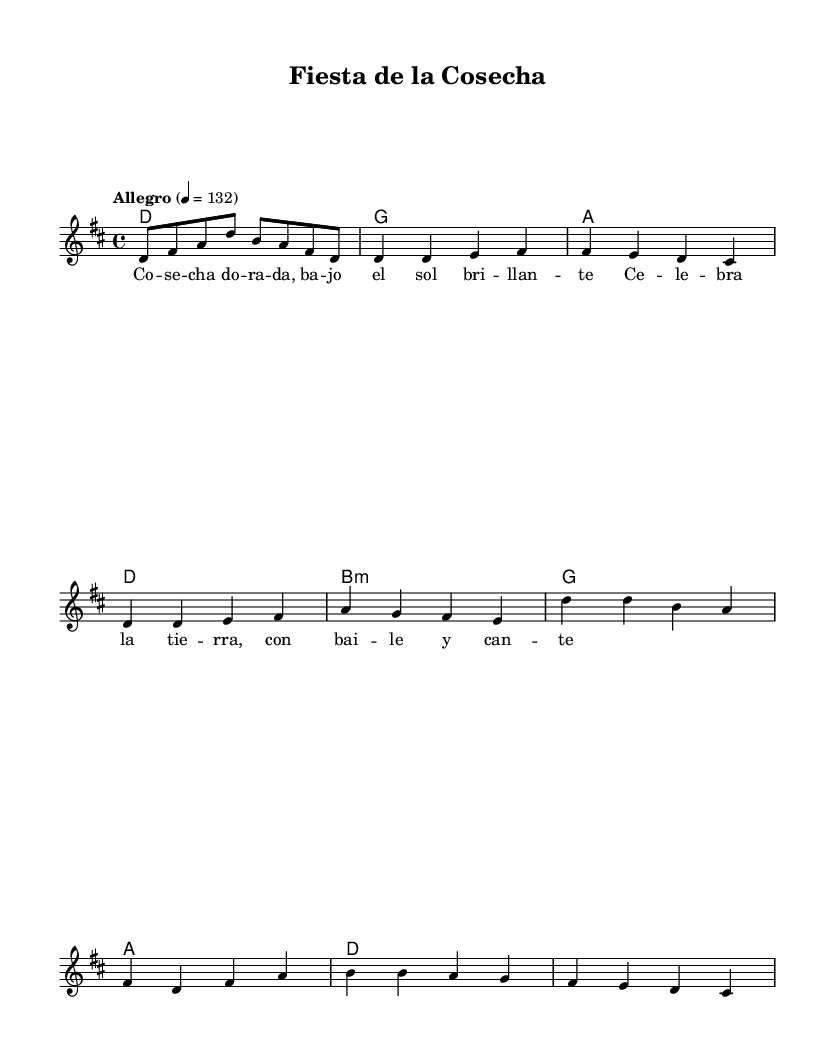What is the key signature of this music? The key signature is indicated by the presence of two sharps (F# and C#) at the beginning of the staff, which denotes the key of D major.
Answer: D major What is the time signature of this music? The time signature is noted as 4/4 at the beginning of the score, indicating that there are four beats in each measure.
Answer: 4/4 What is the tempo marking for this music? The tempo marking indicates "Allegro" with a metronome marking of 132 beats per minute, suggesting a fast and lively tempo.
Answer: Allegro, 132 How many bars are there in the melody before reaching the chorus? By counting the measures in the melody section (Intro + Verse), there are a total of six measures before the chorus section starts.
Answer: 6 Which chord is played in the first measure? The first measure shows a D major chord, indicated by the chord name placed beneath the staff that corresponds to the notes being played above.
Answer: D What type of lyrical theme does this piece convey? The lyrics paint a picture of agricultural celebration and joy, linking to the festivals and harvests central to the atmosphere of the piece.
Answer: Agricultural celebration What is the last note of the melody? The last note of the melody, as indicated in the score, is a C sharp, shown in the last measure of the piece.
Answer: C sharp 